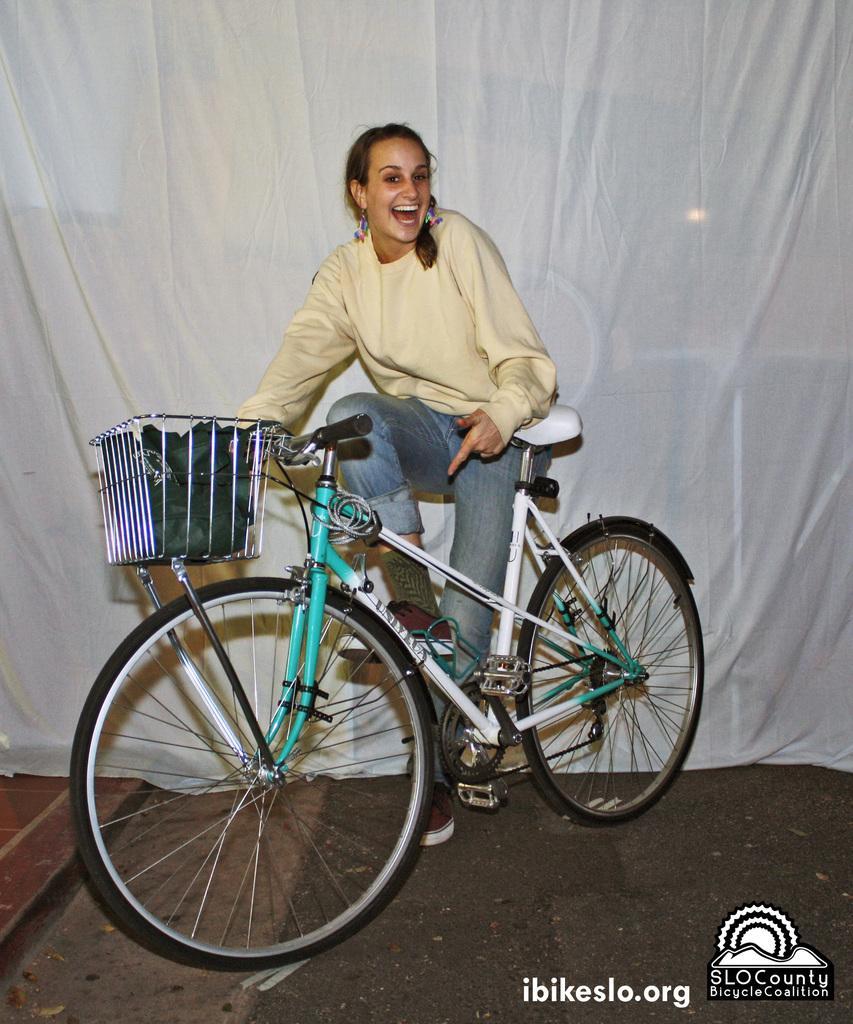Describe this image in one or two sentences. In the image in the center we can see one woman standing and she is smiling,which we can see on her face. And we can see one cycle and one bag. On the right bottom of the image,there is a watermark and logo. In the background there is a white color curtain. 